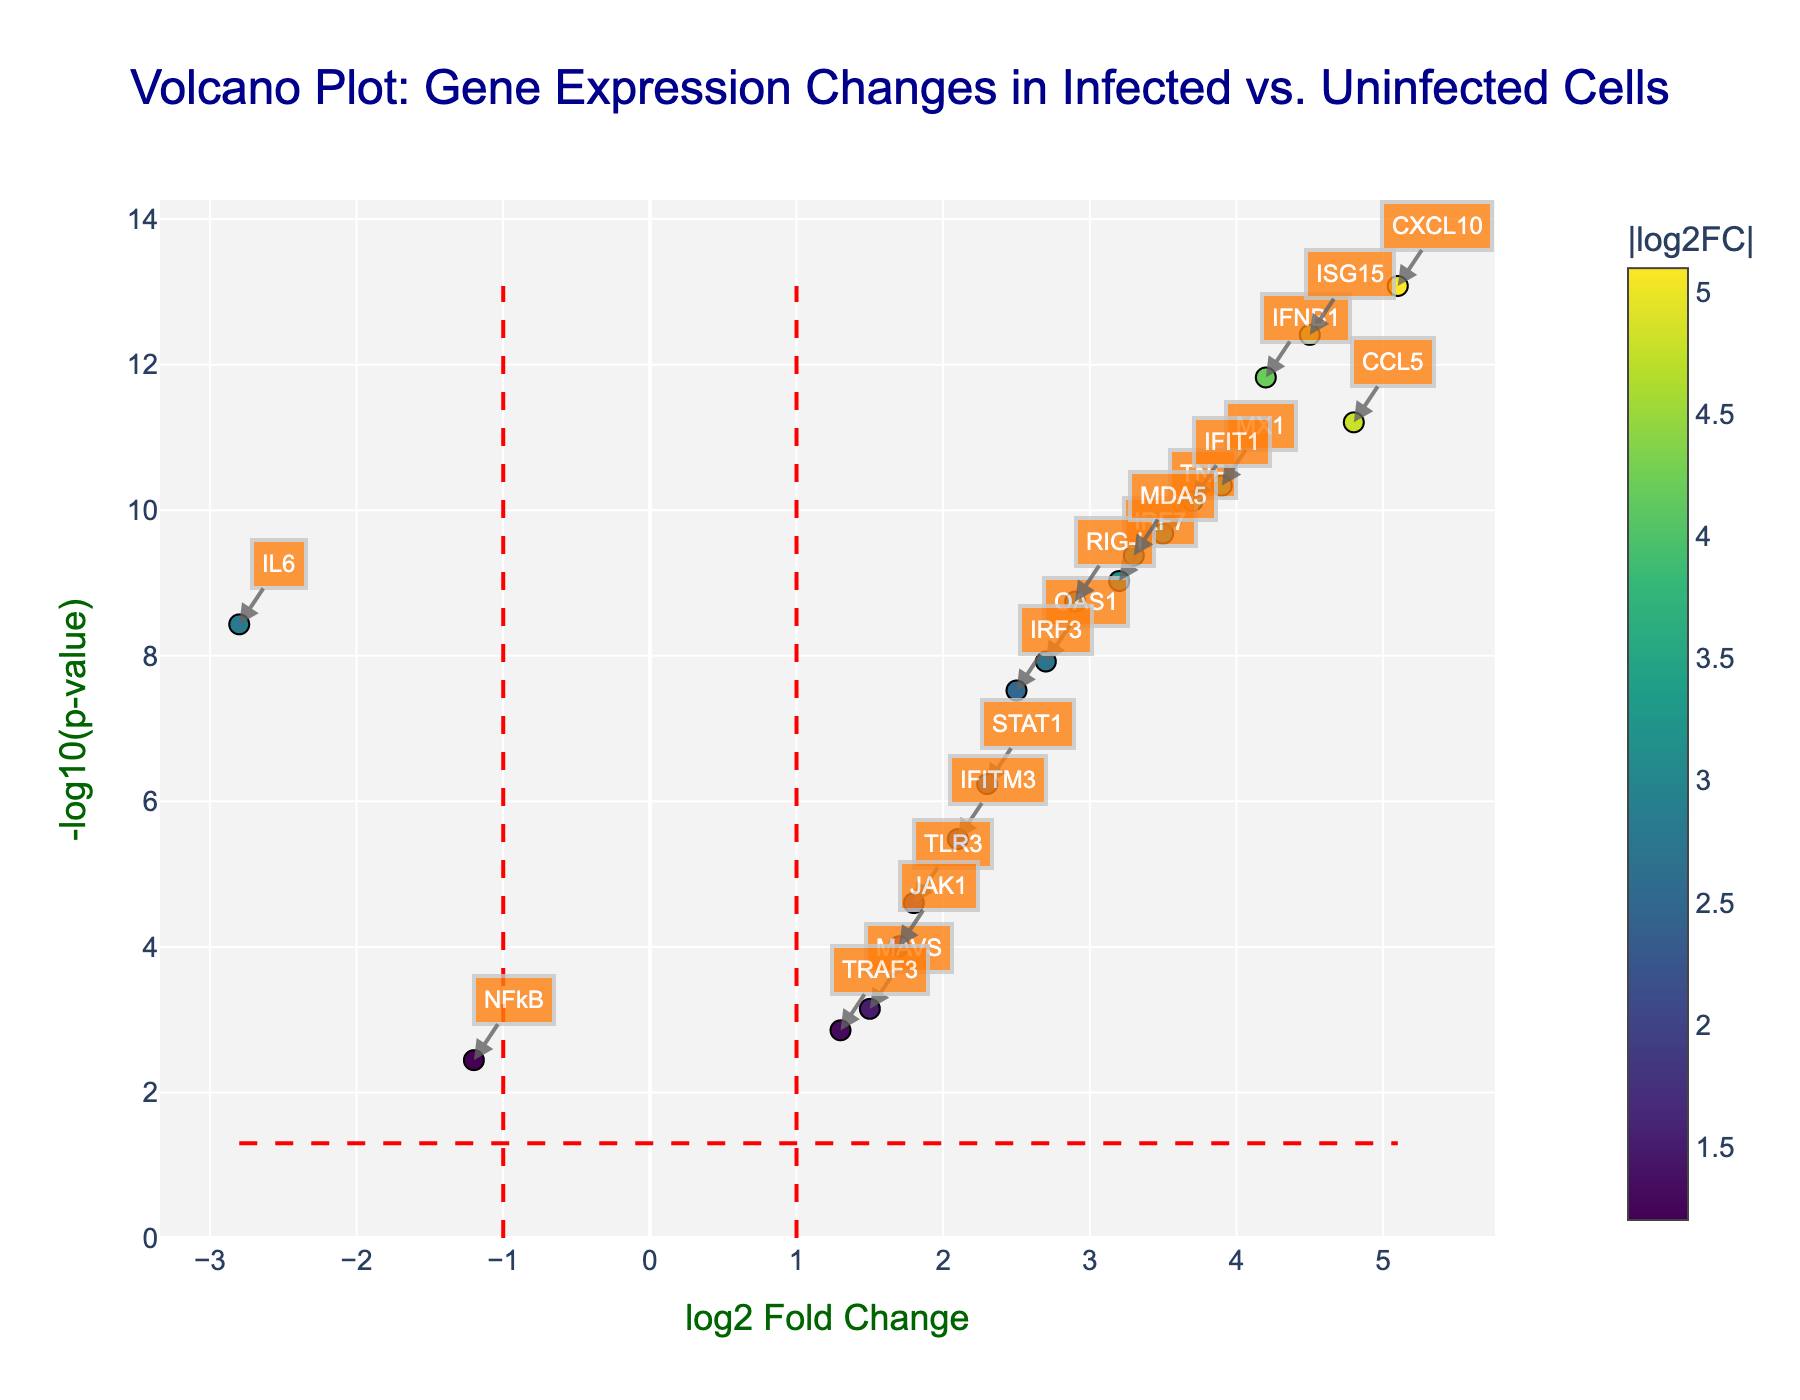What is the title of the figure? The title can be found at the top of the figure in larger font size and usually a different color for emphasis. In this case, the title is explicitly written in the code provided.
Answer: "Volcano Plot: Gene Expression Changes in Infected vs. Uninfected Cells" What do the x and y axes represent in this plot? The x-axis title 'log2 Fold Change' and the y-axis title '-log10(p-value)' are indicated in the plot's axis labels. You can see these labels directly below the x-axis and beside the y-axis, showing the scales used.
Answer: The x-axis represents 'log2 Fold Change' and the y-axis represents '-log10(p-value)' How many genes have a log2 fold change greater than 4? To determine this, identify all genes with log2 fold change values located greater than 4 on the x-axis. Each point represents a gene, and you can count those farther than 4 units to the right.
Answer: 3 Which gene has the highest -log10(p-value) and where is it located? The highest value on the y-axis (-log10(p-value)) can be found by looking for the point that is highest up on the plot. The hover text or annotations will help identify the gene.
Answer: CXCL10 How many genes are considered statistically significant with both p < 0.05 and log2 fold change > 1? Look for genes where points fall outside the threshold lines for significance, i.e., those below -log10(0.05) on the y-axis and beyond ±1 on the x-axis. Annotations and point density can help in counting these.
Answer: 13 Which gene has the lowest log2 fold change and what is its -log10(p-value)? Identify the leftmost point on the x-axis, which corresponds to the lowest log2 fold change. Check its y-axis value to see the -log10(p-value).
Answer: IL6, ~8.43 Compare the expression levels of IFNB1 and IL6. Which one shows upregulation and which one shows downregulation? To compare, locate points representing IFNB1 and IL6. The x-axis value will indicate upregulation (positive) or downregulation (negative). This interpretation can be confirmed via the hover info or annotations.
Answer: IFNB1 is upregulated, IL6 is downregulated How is statistical significance shown on this plot? Statistical significance is illustrated using threshold lines on the plot, visible as dashed red lines: one horizontal (-log10(p-value) = 1.3) and two vertical lines (log2 Fold Change = ±1). Points beyond these lines are considered significant.
Answer: By dashed red lines What is the log2 fold change and p-value for MX1? Locate the point for MX1 either by visual inspection or using annotations/hover info on the plot. The x-axis value gives log2 fold change, and hovering or annotations will reveal the p-value.
Answer: log2 Fold Change: 3.9, p-value: 4.6e-11 What color coding scheme is used to depict the log2 fold change values? The color of the points is determined by the log2 fold change values. The scheme (Viridis colorscale) ranges from one color representing lower values to another representing higher values, as indicated by the color bar.
Answer: Colorscale (Viridis colorscale) based on log2 fold change 